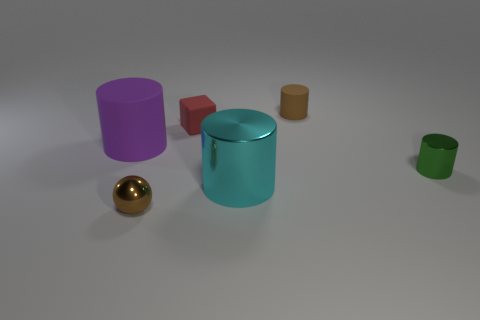Is the color of the small matte cylinder the same as the tiny shiny ball?
Give a very brief answer. Yes. What number of objects are tiny blue metal cylinders or tiny brown things that are to the left of the red matte thing?
Offer a terse response. 1. Are there fewer cylinders than red cubes?
Offer a terse response. No. Is the number of cyan shiny things greater than the number of purple metal cubes?
Offer a very short reply. Yes. What number of other objects are there of the same material as the purple cylinder?
Give a very brief answer. 2. How many big purple cylinders are on the right side of the rubber cylinder left of the small thing in front of the large cyan thing?
Provide a short and direct response. 0. How many matte objects are big gray blocks or red cubes?
Provide a short and direct response. 1. What size is the metal cylinder that is in front of the tiny shiny object behind the big cyan cylinder?
Offer a terse response. Large. There is a matte object that is on the right side of the red matte block; is it the same color as the tiny thing in front of the cyan metal cylinder?
Provide a succinct answer. Yes. There is a tiny object that is in front of the red cube and behind the small sphere; what is its color?
Ensure brevity in your answer.  Green. 